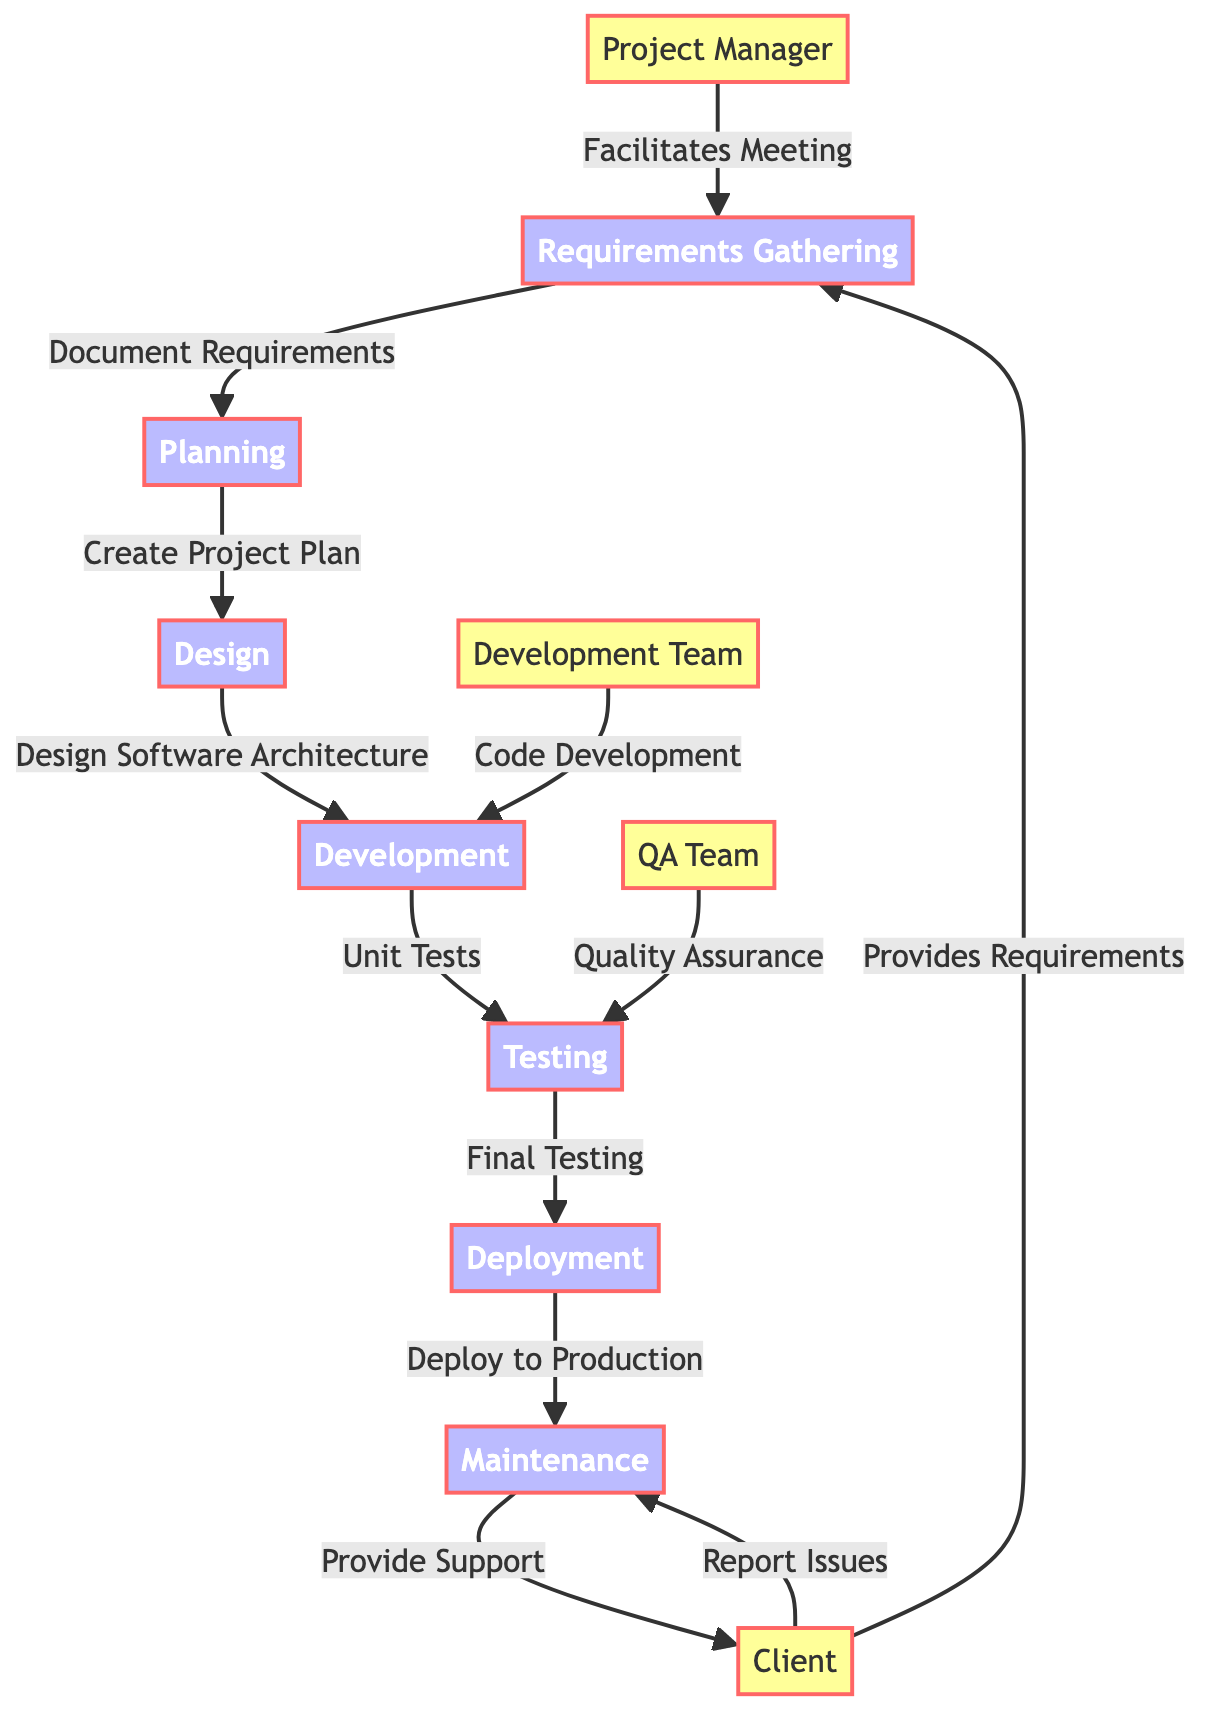What is the first step in the software development lifecycle? The diagram shows that the first step in the software development lifecycle is "Requirements Gathering." It is the initial node where both the client and the project manager interact to provide and facilitate requirements.
Answer: Requirements Gathering Who provides requirements in the diagram? According to the diagram, the "Client" is the entity that provides requirements. The arrow from the client to the requirements gathering node indicates this relationship.
Answer: Client What is the relationship between planning and design? The diagram indicates that planning is followed by design, as there is a direct arrow from the planning node to the design node labeled "Create Project Plan." This signifies that planning leads to design.
Answer: Create Project Plan How many teams are involved in the testing phase? In the diagram, there are two teams involved in the testing phase: the "Development Team" and the "QA Team." Both teams contribute to the testing process, as indicated by separate arrows pointing to the testing node.
Answer: Two Which phase comes immediately after deployment? According to the flow of the diagram, the phase that comes immediately after deployment is "Maintenance." This is evident from the direct arrow leading from the deployment node to the maintenance node.
Answer: Maintenance What role does the project manager play in the requirements gathering phase? The diagram specifies that the "Project Manager" facilitates meetings during the requirements gathering phase. This is represented by the arrow from the project manager to the requirements gathering node labeled "Facilitates Meeting."
Answer: Facilitates Meeting What is the last step that involves the client in the software development lifecycle? The diagram indicates that the last step involving the client is during the maintenance phase, where the client reports issues. This is shown by the arrow from the client node back to the maintenance node.
Answer: Report Issues How does the development team contribute during development? The diagram shows that the "Development Team" contributes to the development phase through "Code Development." This is illustrated by the arrow leading from the development team to the development node.
Answer: Code Development What is the final testing called in the lifecycle? The final testing phase in the software development lifecycle, as indicated in the diagram, is called "Final Testing." This is explicitly mentioned as the step leading to deployment.
Answer: Final Testing 